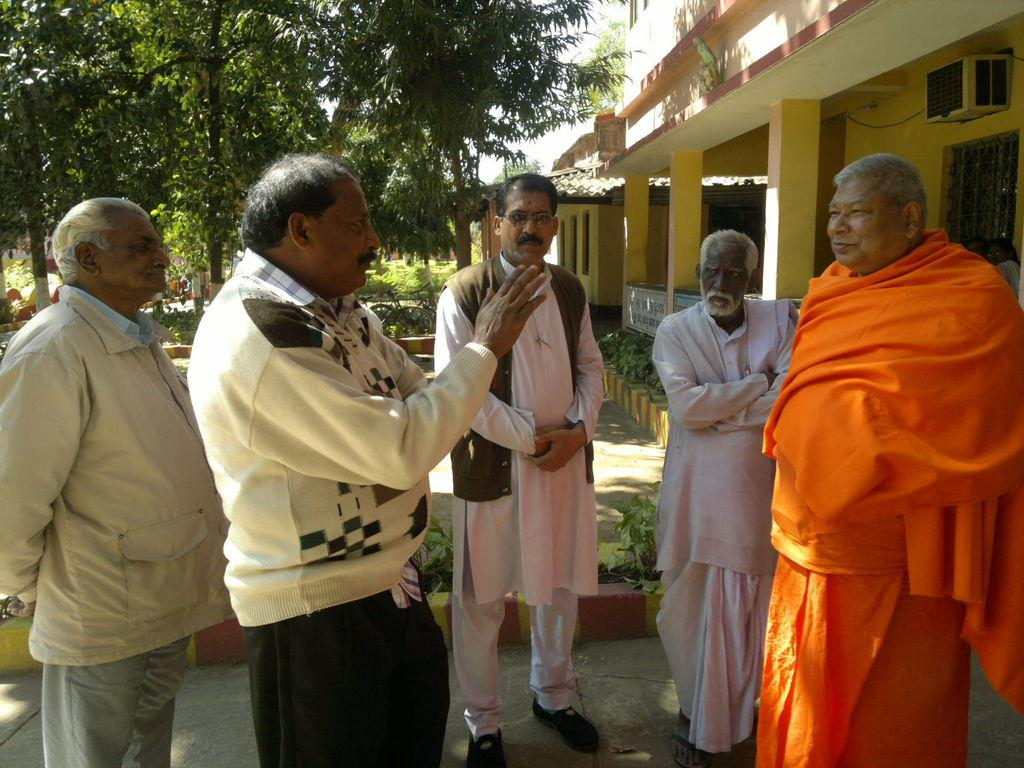How many people are present in the image? There are five persons standing in the image. What type of structures can be seen in the image? There are houses in the image. What type of vegetation is present in the image? There are plants and trees in the image. What is visible in the background of the image? The sky is visible in the image. What type of bean is being used as a seat in the image? There is no bean present in the image, let alone one being used as a seat. 